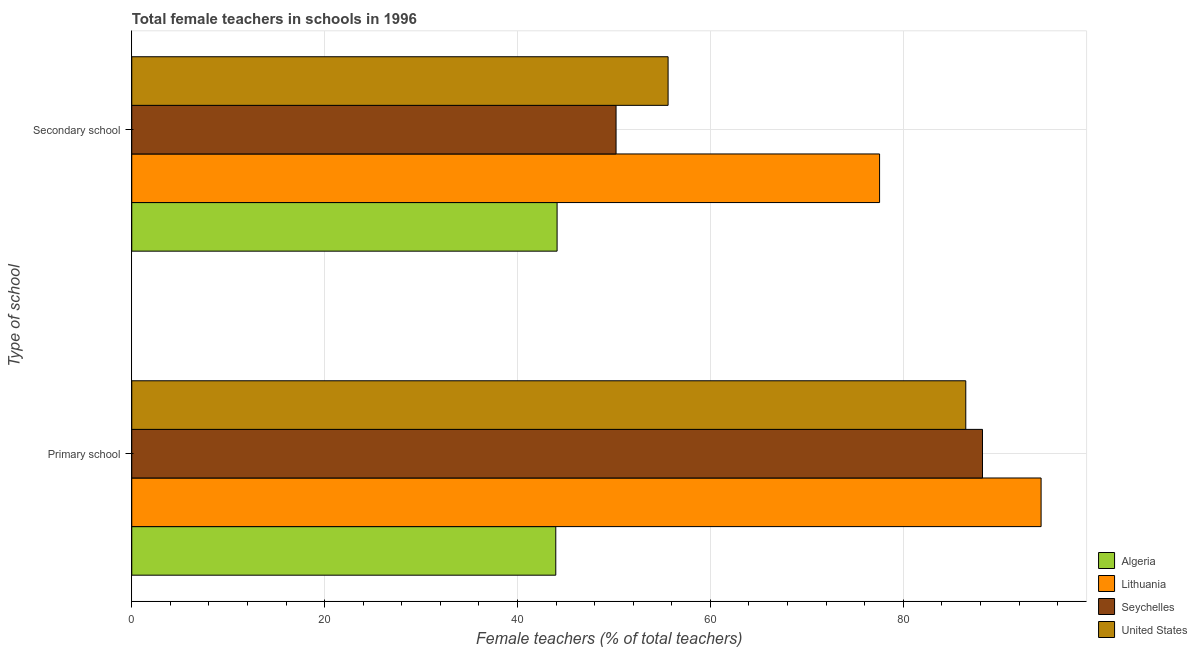How many different coloured bars are there?
Give a very brief answer. 4. How many groups of bars are there?
Your response must be concise. 2. How many bars are there on the 2nd tick from the top?
Ensure brevity in your answer.  4. How many bars are there on the 1st tick from the bottom?
Provide a succinct answer. 4. What is the label of the 1st group of bars from the top?
Make the answer very short. Secondary school. What is the percentage of female teachers in primary schools in United States?
Provide a short and direct response. 86.48. Across all countries, what is the maximum percentage of female teachers in secondary schools?
Give a very brief answer. 77.54. Across all countries, what is the minimum percentage of female teachers in primary schools?
Your response must be concise. 43.97. In which country was the percentage of female teachers in primary schools maximum?
Your answer should be very brief. Lithuania. In which country was the percentage of female teachers in secondary schools minimum?
Give a very brief answer. Algeria. What is the total percentage of female teachers in primary schools in the graph?
Provide a short and direct response. 312.96. What is the difference between the percentage of female teachers in primary schools in Lithuania and that in United States?
Make the answer very short. 7.81. What is the difference between the percentage of female teachers in secondary schools in Algeria and the percentage of female teachers in primary schools in United States?
Provide a short and direct response. -42.38. What is the average percentage of female teachers in primary schools per country?
Provide a succinct answer. 78.24. What is the difference between the percentage of female teachers in primary schools and percentage of female teachers in secondary schools in Algeria?
Ensure brevity in your answer.  -0.14. What is the ratio of the percentage of female teachers in primary schools in Lithuania to that in Algeria?
Your answer should be compact. 2.14. Is the percentage of female teachers in primary schools in United States less than that in Lithuania?
Provide a succinct answer. Yes. In how many countries, is the percentage of female teachers in secondary schools greater than the average percentage of female teachers in secondary schools taken over all countries?
Your response must be concise. 1. What does the 1st bar from the top in Primary school represents?
Your answer should be compact. United States. How many bars are there?
Your response must be concise. 8. How many countries are there in the graph?
Offer a terse response. 4. Are the values on the major ticks of X-axis written in scientific E-notation?
Your answer should be very brief. No. Does the graph contain grids?
Your response must be concise. Yes. Where does the legend appear in the graph?
Provide a succinct answer. Bottom right. How are the legend labels stacked?
Ensure brevity in your answer.  Vertical. What is the title of the graph?
Provide a succinct answer. Total female teachers in schools in 1996. What is the label or title of the X-axis?
Offer a very short reply. Female teachers (% of total teachers). What is the label or title of the Y-axis?
Ensure brevity in your answer.  Type of school. What is the Female teachers (% of total teachers) of Algeria in Primary school?
Your answer should be very brief. 43.97. What is the Female teachers (% of total teachers) in Lithuania in Primary school?
Provide a succinct answer. 94.29. What is the Female teachers (% of total teachers) of Seychelles in Primary school?
Provide a succinct answer. 88.21. What is the Female teachers (% of total teachers) in United States in Primary school?
Give a very brief answer. 86.48. What is the Female teachers (% of total teachers) in Algeria in Secondary school?
Ensure brevity in your answer.  44.1. What is the Female teachers (% of total teachers) of Lithuania in Secondary school?
Provide a succinct answer. 77.54. What is the Female teachers (% of total teachers) of Seychelles in Secondary school?
Provide a short and direct response. 50.22. What is the Female teachers (% of total teachers) of United States in Secondary school?
Ensure brevity in your answer.  55.61. Across all Type of school, what is the maximum Female teachers (% of total teachers) in Algeria?
Offer a terse response. 44.1. Across all Type of school, what is the maximum Female teachers (% of total teachers) of Lithuania?
Provide a short and direct response. 94.29. Across all Type of school, what is the maximum Female teachers (% of total teachers) of Seychelles?
Your answer should be compact. 88.21. Across all Type of school, what is the maximum Female teachers (% of total teachers) of United States?
Your answer should be very brief. 86.48. Across all Type of school, what is the minimum Female teachers (% of total teachers) of Algeria?
Ensure brevity in your answer.  43.97. Across all Type of school, what is the minimum Female teachers (% of total teachers) in Lithuania?
Offer a very short reply. 77.54. Across all Type of school, what is the minimum Female teachers (% of total teachers) of Seychelles?
Your response must be concise. 50.22. Across all Type of school, what is the minimum Female teachers (% of total teachers) of United States?
Your answer should be compact. 55.61. What is the total Female teachers (% of total teachers) of Algeria in the graph?
Provide a short and direct response. 88.07. What is the total Female teachers (% of total teachers) of Lithuania in the graph?
Give a very brief answer. 171.83. What is the total Female teachers (% of total teachers) of Seychelles in the graph?
Offer a very short reply. 138.43. What is the total Female teachers (% of total teachers) in United States in the graph?
Keep it short and to the point. 142.1. What is the difference between the Female teachers (% of total teachers) in Algeria in Primary school and that in Secondary school?
Provide a succinct answer. -0.14. What is the difference between the Female teachers (% of total teachers) of Lithuania in Primary school and that in Secondary school?
Ensure brevity in your answer.  16.75. What is the difference between the Female teachers (% of total teachers) of Seychelles in Primary school and that in Secondary school?
Offer a terse response. 38. What is the difference between the Female teachers (% of total teachers) of United States in Primary school and that in Secondary school?
Offer a very short reply. 30.87. What is the difference between the Female teachers (% of total teachers) in Algeria in Primary school and the Female teachers (% of total teachers) in Lithuania in Secondary school?
Keep it short and to the point. -33.58. What is the difference between the Female teachers (% of total teachers) in Algeria in Primary school and the Female teachers (% of total teachers) in Seychelles in Secondary school?
Provide a succinct answer. -6.25. What is the difference between the Female teachers (% of total teachers) in Algeria in Primary school and the Female teachers (% of total teachers) in United States in Secondary school?
Offer a very short reply. -11.65. What is the difference between the Female teachers (% of total teachers) of Lithuania in Primary school and the Female teachers (% of total teachers) of Seychelles in Secondary school?
Your answer should be compact. 44.07. What is the difference between the Female teachers (% of total teachers) in Lithuania in Primary school and the Female teachers (% of total teachers) in United States in Secondary school?
Ensure brevity in your answer.  38.68. What is the difference between the Female teachers (% of total teachers) of Seychelles in Primary school and the Female teachers (% of total teachers) of United States in Secondary school?
Make the answer very short. 32.6. What is the average Female teachers (% of total teachers) in Algeria per Type of school?
Keep it short and to the point. 44.04. What is the average Female teachers (% of total teachers) in Lithuania per Type of school?
Give a very brief answer. 85.92. What is the average Female teachers (% of total teachers) in Seychelles per Type of school?
Make the answer very short. 69.22. What is the average Female teachers (% of total teachers) of United States per Type of school?
Offer a very short reply. 71.05. What is the difference between the Female teachers (% of total teachers) of Algeria and Female teachers (% of total teachers) of Lithuania in Primary school?
Offer a very short reply. -50.32. What is the difference between the Female teachers (% of total teachers) in Algeria and Female teachers (% of total teachers) in Seychelles in Primary school?
Your answer should be very brief. -44.25. What is the difference between the Female teachers (% of total teachers) of Algeria and Female teachers (% of total teachers) of United States in Primary school?
Your answer should be compact. -42.52. What is the difference between the Female teachers (% of total teachers) of Lithuania and Female teachers (% of total teachers) of Seychelles in Primary school?
Make the answer very short. 6.08. What is the difference between the Female teachers (% of total teachers) in Lithuania and Female teachers (% of total teachers) in United States in Primary school?
Offer a terse response. 7.81. What is the difference between the Female teachers (% of total teachers) of Seychelles and Female teachers (% of total teachers) of United States in Primary school?
Your answer should be compact. 1.73. What is the difference between the Female teachers (% of total teachers) in Algeria and Female teachers (% of total teachers) in Lithuania in Secondary school?
Give a very brief answer. -33.44. What is the difference between the Female teachers (% of total teachers) of Algeria and Female teachers (% of total teachers) of Seychelles in Secondary school?
Provide a succinct answer. -6.11. What is the difference between the Female teachers (% of total teachers) of Algeria and Female teachers (% of total teachers) of United States in Secondary school?
Offer a terse response. -11.51. What is the difference between the Female teachers (% of total teachers) in Lithuania and Female teachers (% of total teachers) in Seychelles in Secondary school?
Offer a terse response. 27.33. What is the difference between the Female teachers (% of total teachers) of Lithuania and Female teachers (% of total teachers) of United States in Secondary school?
Make the answer very short. 21.93. What is the difference between the Female teachers (% of total teachers) in Seychelles and Female teachers (% of total teachers) in United States in Secondary school?
Your answer should be compact. -5.4. What is the ratio of the Female teachers (% of total teachers) of Algeria in Primary school to that in Secondary school?
Make the answer very short. 1. What is the ratio of the Female teachers (% of total teachers) in Lithuania in Primary school to that in Secondary school?
Provide a short and direct response. 1.22. What is the ratio of the Female teachers (% of total teachers) in Seychelles in Primary school to that in Secondary school?
Your answer should be very brief. 1.76. What is the ratio of the Female teachers (% of total teachers) in United States in Primary school to that in Secondary school?
Make the answer very short. 1.56. What is the difference between the highest and the second highest Female teachers (% of total teachers) of Algeria?
Your response must be concise. 0.14. What is the difference between the highest and the second highest Female teachers (% of total teachers) in Lithuania?
Offer a terse response. 16.75. What is the difference between the highest and the second highest Female teachers (% of total teachers) in Seychelles?
Offer a very short reply. 38. What is the difference between the highest and the second highest Female teachers (% of total teachers) in United States?
Give a very brief answer. 30.87. What is the difference between the highest and the lowest Female teachers (% of total teachers) of Algeria?
Make the answer very short. 0.14. What is the difference between the highest and the lowest Female teachers (% of total teachers) of Lithuania?
Offer a very short reply. 16.75. What is the difference between the highest and the lowest Female teachers (% of total teachers) in Seychelles?
Your answer should be very brief. 38. What is the difference between the highest and the lowest Female teachers (% of total teachers) of United States?
Give a very brief answer. 30.87. 